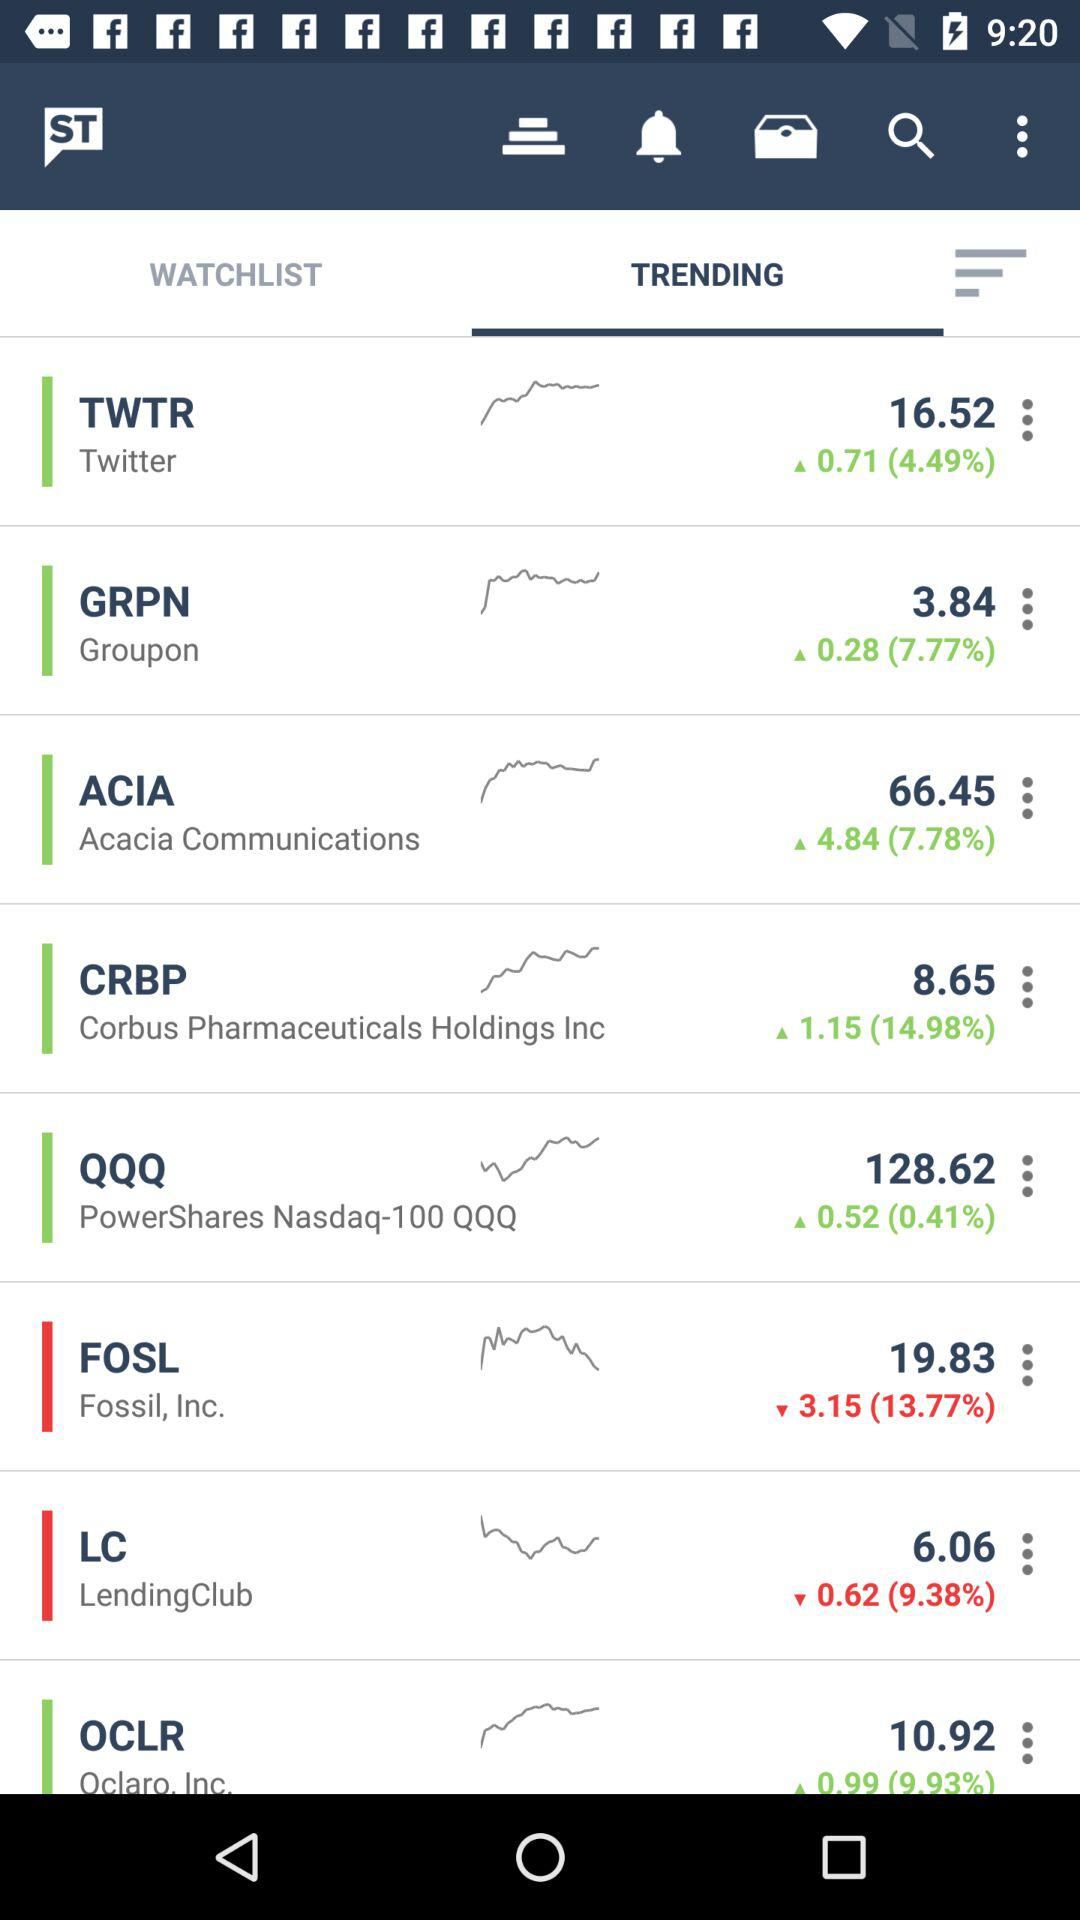What is the percentage loss on the stock price of "Fossil, Inc."? The percentage loss is 13.77%. 